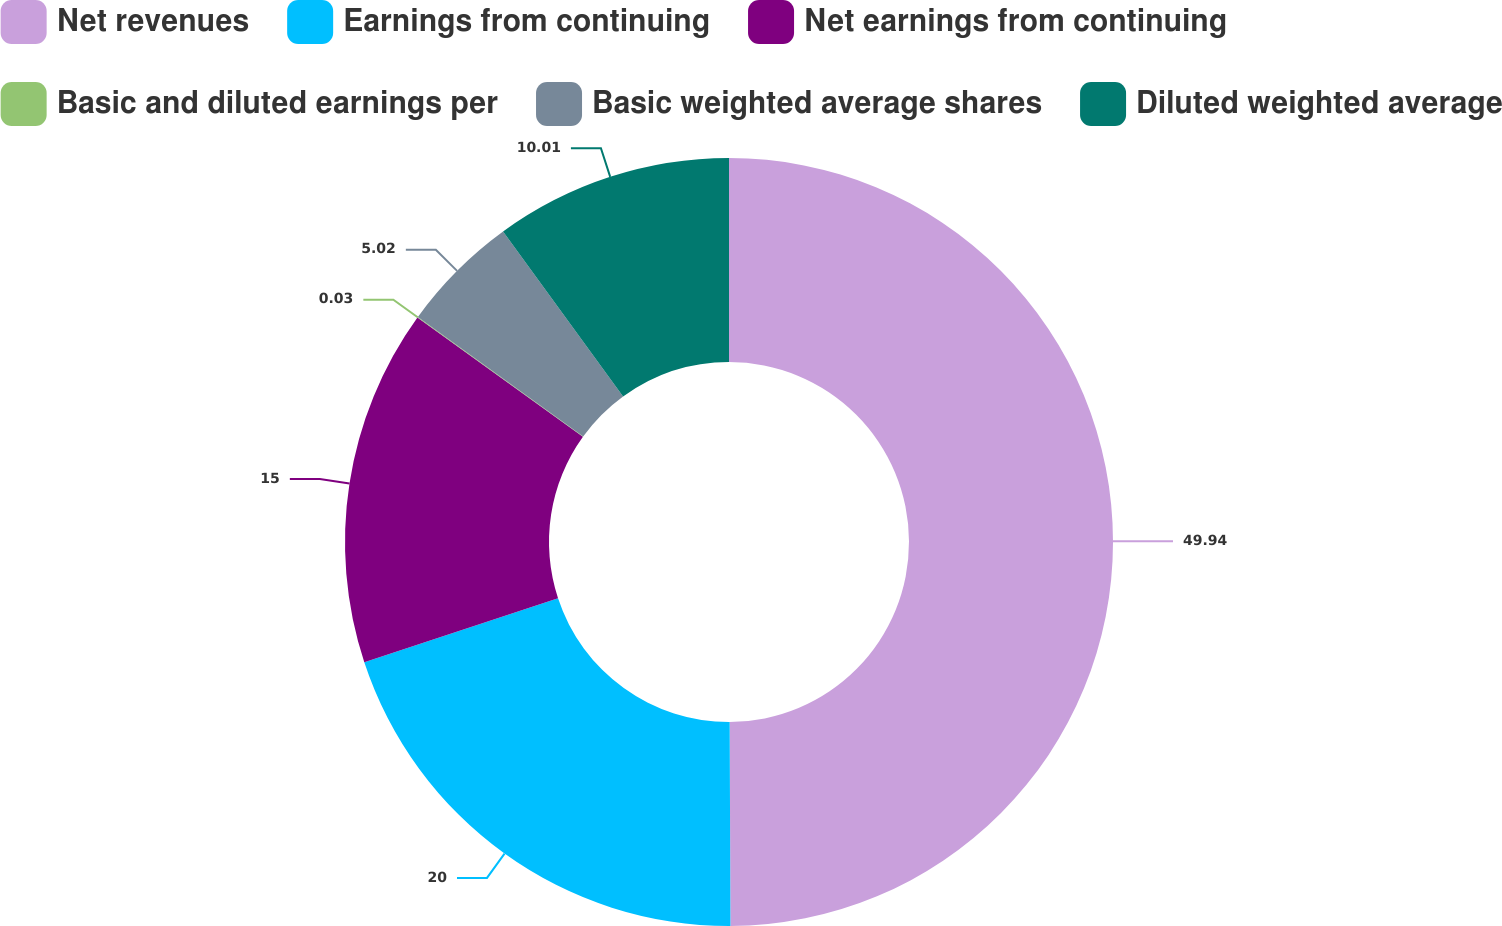<chart> <loc_0><loc_0><loc_500><loc_500><pie_chart><fcel>Net revenues<fcel>Earnings from continuing<fcel>Net earnings from continuing<fcel>Basic and diluted earnings per<fcel>Basic weighted average shares<fcel>Diluted weighted average<nl><fcel>49.93%<fcel>19.99%<fcel>15.0%<fcel>0.03%<fcel>5.02%<fcel>10.01%<nl></chart> 